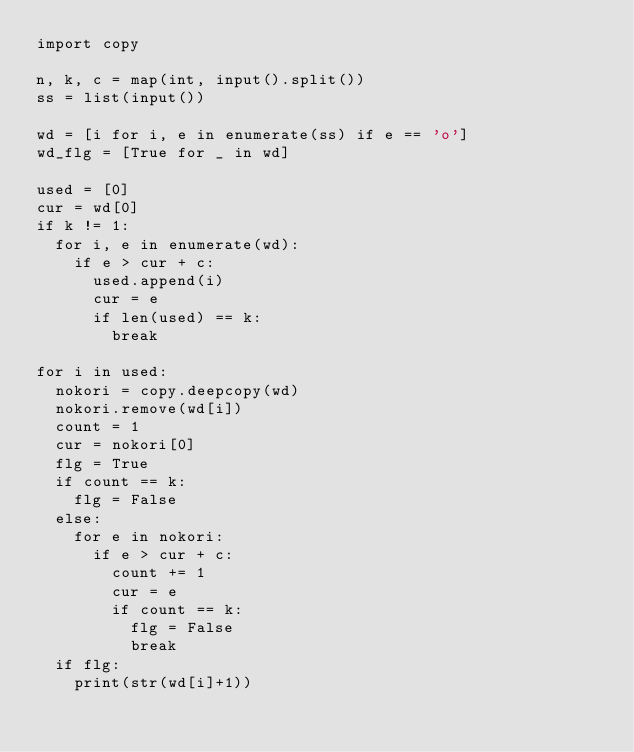Convert code to text. <code><loc_0><loc_0><loc_500><loc_500><_Python_>import copy

n, k, c = map(int, input().split())
ss = list(input())

wd = [i for i, e in enumerate(ss) if e == 'o']
wd_flg = [True for _ in wd]

used = [0]
cur = wd[0]
if k != 1:
  for i, e in enumerate(wd):
    if e > cur + c:
      used.append(i)
      cur = e
      if len(used) == k:
        break

for i in used:
  nokori = copy.deepcopy(wd)
  nokori.remove(wd[i])
  count = 1
  cur = nokori[0]
  flg = True
  if count == k:
    flg = False
  else:
    for e in nokori:
      if e > cur + c:
        count += 1
        cur = e
        if count == k:
          flg = False
          break
  if flg:
    print(str(wd[i]+1))</code> 